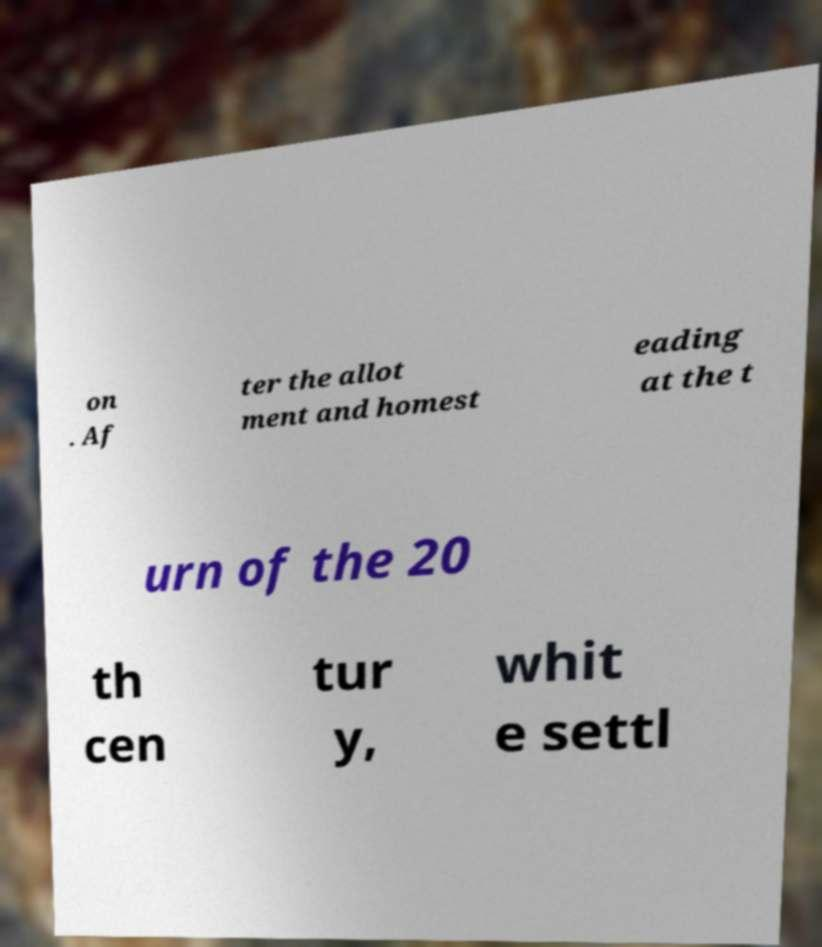Please identify and transcribe the text found in this image. on . Af ter the allot ment and homest eading at the t urn of the 20 th cen tur y, whit e settl 